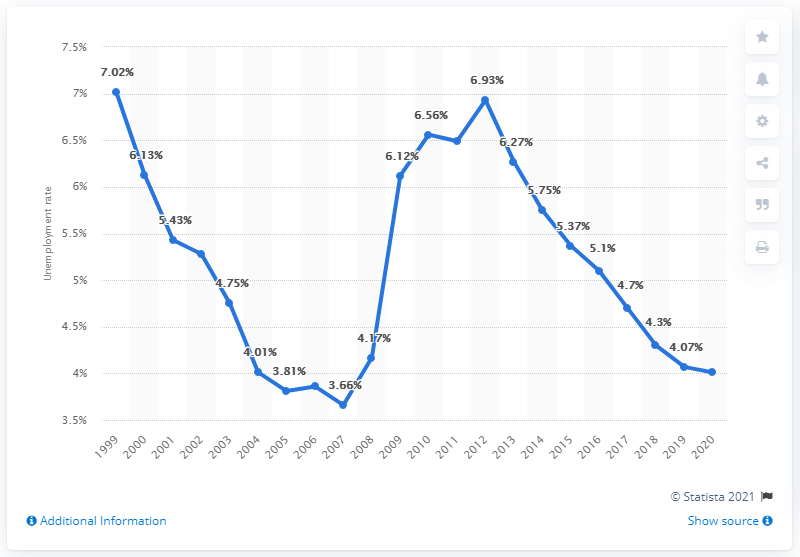List a handful of essential elements in this visual. In 2020, the unemployment rate in New Zealand was 4.01%. The unemployment rate in New Zealand fluctuated between 3.36% in 1999 and 6.9% in 2020, with the lowest rate being recorded in 1999 and the highest rate being recorded in 2020. In 2001, the unemployment rate in New Zealand was 5.43%. 